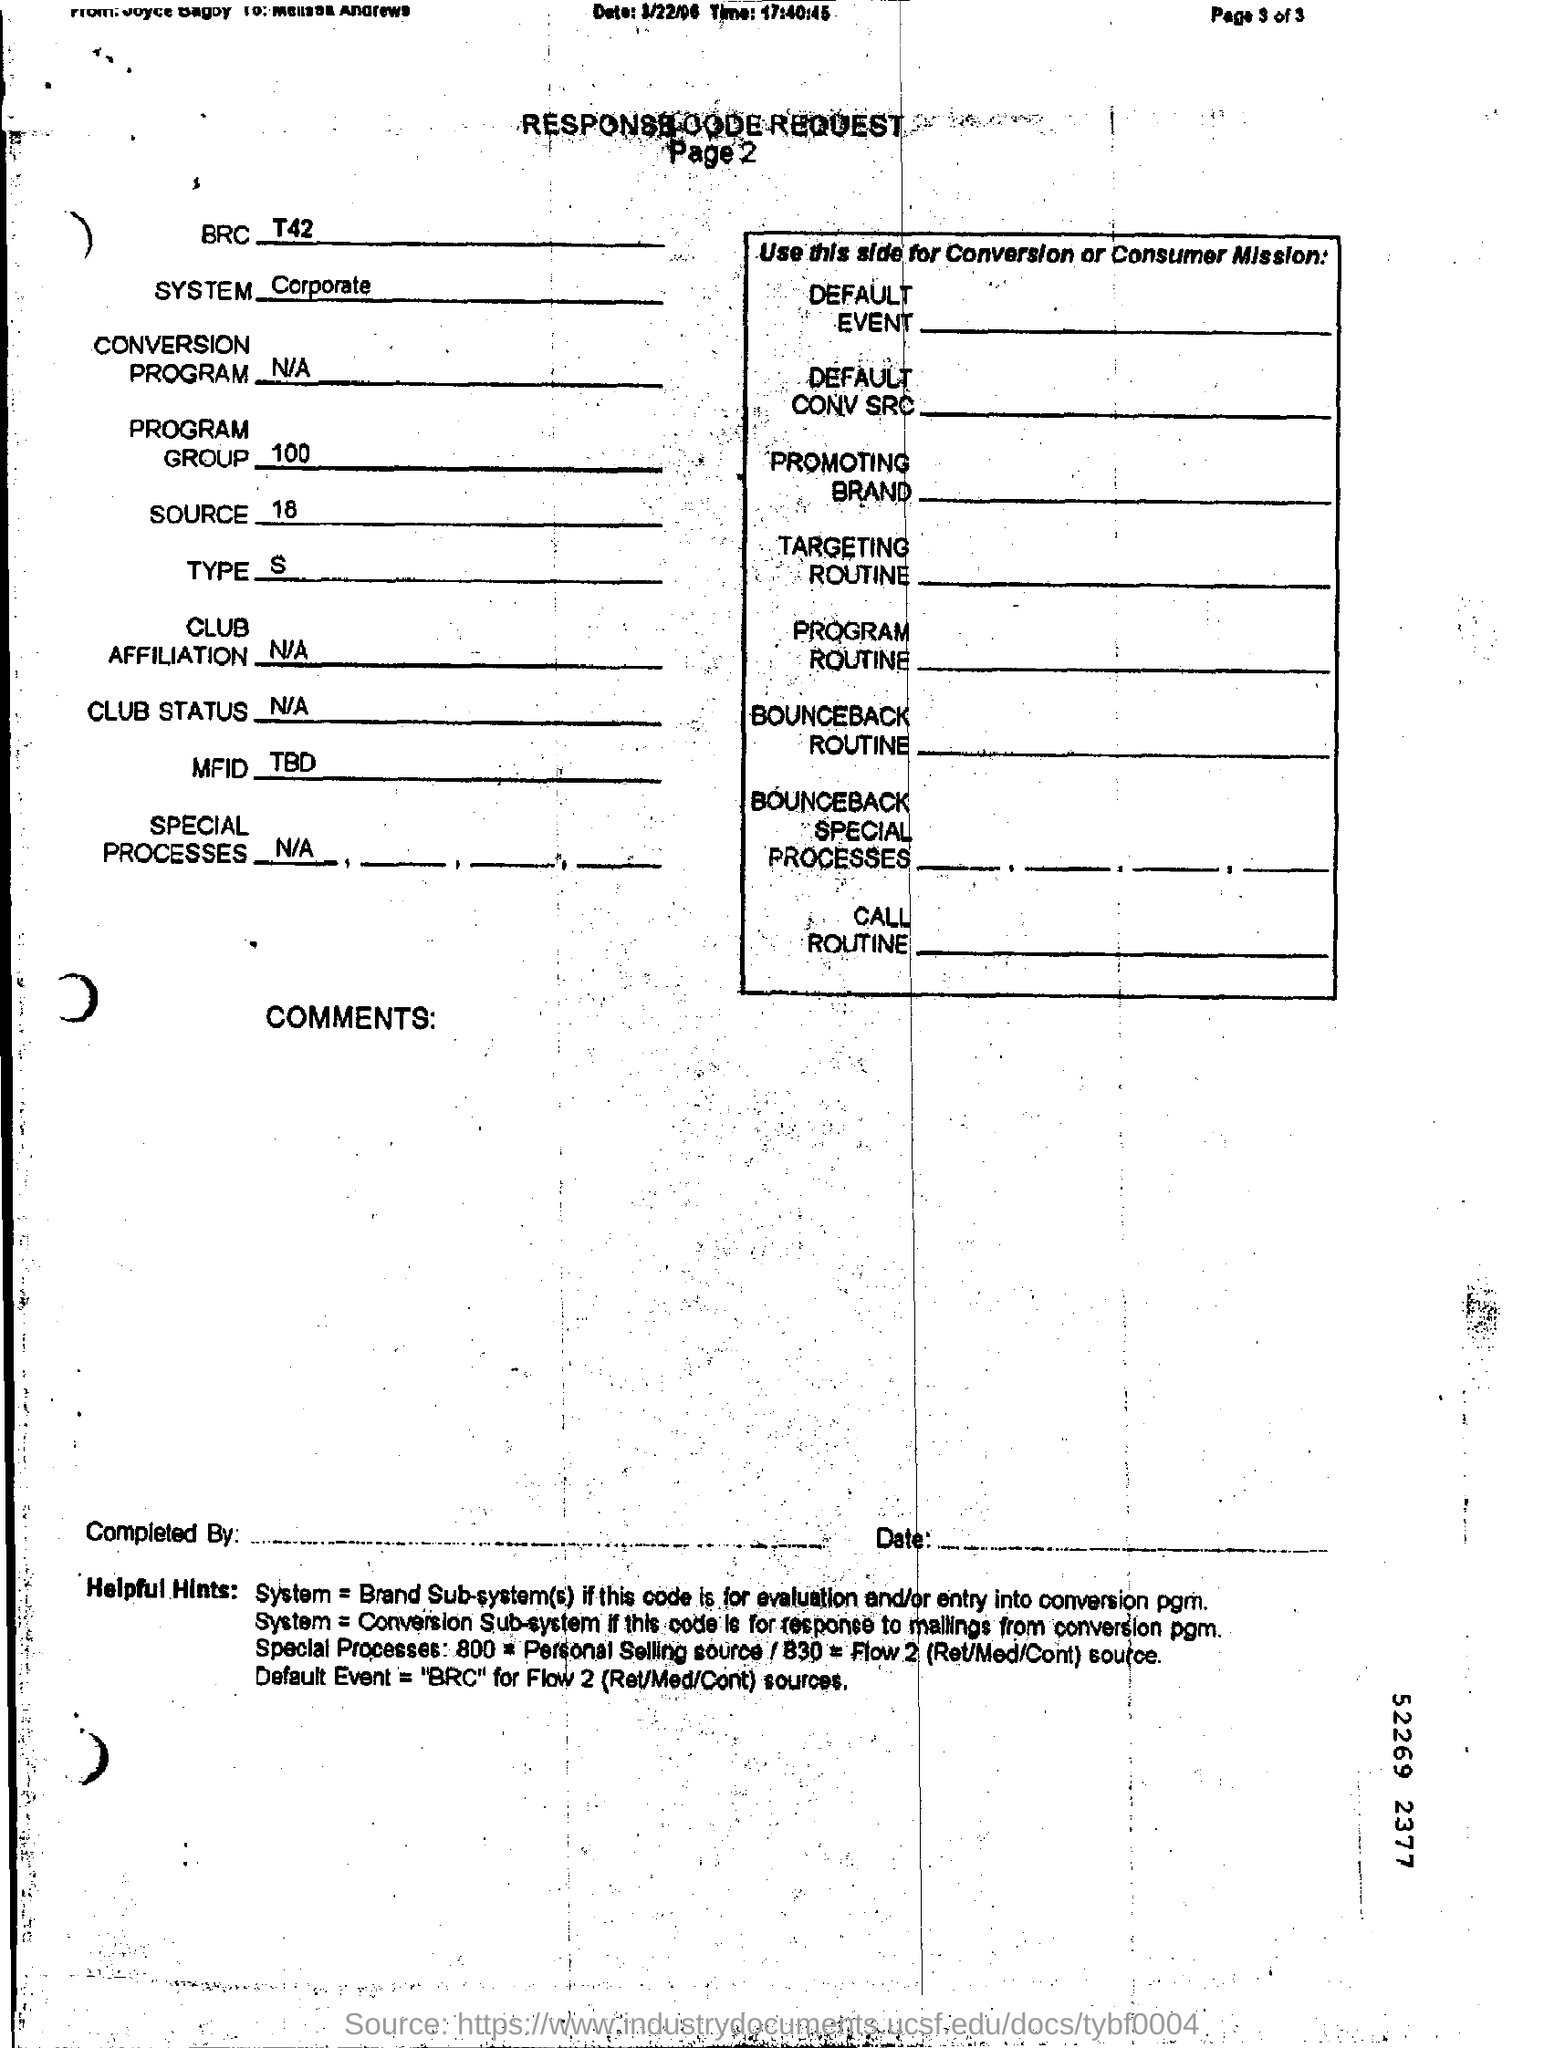Mention a couple of crucial points in this snapshot. The value for the program group is 100. The system is a corporate system. 